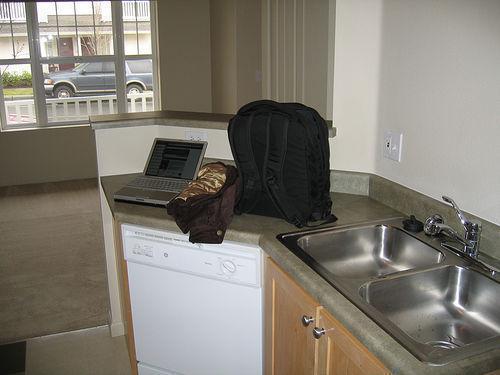Where is someone working?
Indicate the correct response and explain using: 'Answer: answer
Rationale: rationale.'
Options: Home, library, office, courthouse. Answer: home.
Rationale: The laptop and bag are on a counter in a house. 